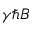<formula> <loc_0><loc_0><loc_500><loc_500>\gamma \hbar { B }</formula> 